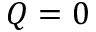<formula> <loc_0><loc_0><loc_500><loc_500>Q = 0</formula> 